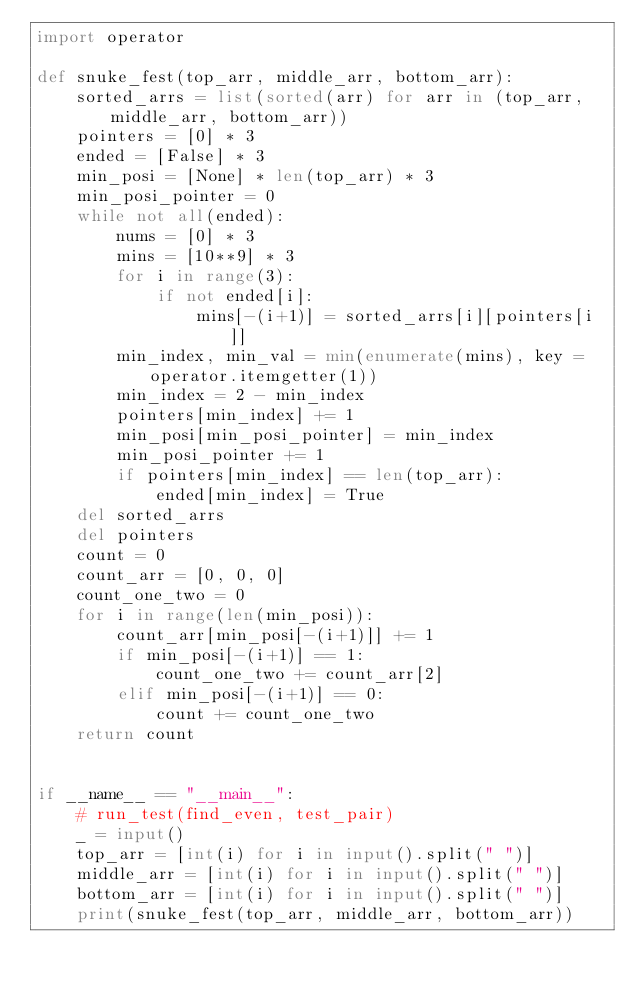Convert code to text. <code><loc_0><loc_0><loc_500><loc_500><_Python_>import operator

def snuke_fest(top_arr, middle_arr, bottom_arr):
    sorted_arrs = list(sorted(arr) for arr in (top_arr, middle_arr, bottom_arr))
    pointers = [0] * 3
    ended = [False] * 3
    min_posi = [None] * len(top_arr) * 3
    min_posi_pointer = 0
    while not all(ended):
        nums = [0] * 3
        mins = [10**9] * 3
        for i in range(3):
            if not ended[i]:
                mins[-(i+1)] = sorted_arrs[i][pointers[i]]
        min_index, min_val = min(enumerate(mins), key = operator.itemgetter(1))
        min_index = 2 - min_index
        pointers[min_index] += 1
        min_posi[min_posi_pointer] = min_index
        min_posi_pointer += 1
        if pointers[min_index] == len(top_arr):
            ended[min_index] = True
    del sorted_arrs
    del pointers
    count = 0
    count_arr = [0, 0, 0]
    count_one_two = 0
    for i in range(len(min_posi)):
        count_arr[min_posi[-(i+1)]] += 1
        if min_posi[-(i+1)] == 1:
            count_one_two += count_arr[2]
        elif min_posi[-(i+1)] == 0:
            count += count_one_two
    return count


if __name__ == "__main__":
    # run_test(find_even, test_pair)
    _ = input()
    top_arr = [int(i) for i in input().split(" ")]
    middle_arr = [int(i) for i in input().split(" ")]
    bottom_arr = [int(i) for i in input().split(" ")]
    print(snuke_fest(top_arr, middle_arr, bottom_arr))</code> 